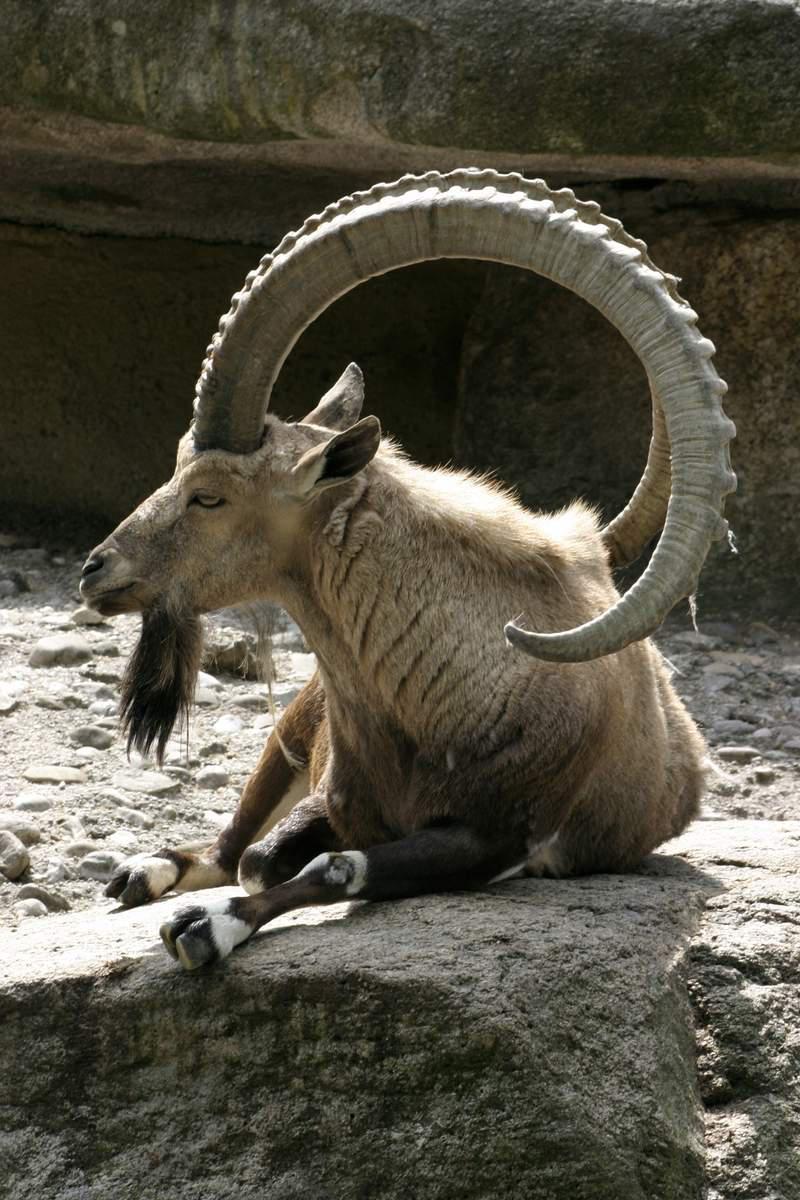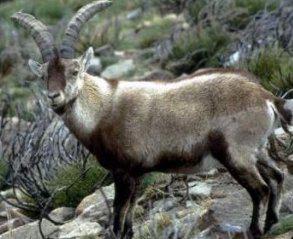The first image is the image on the left, the second image is the image on the right. Given the left and right images, does the statement "The left image contains one reclining long-horned goat, and the right image contains one long-horned goat standing in profile." hold true? Answer yes or no. Yes. The first image is the image on the left, the second image is the image on the right. Given the left and right images, does the statement "An ibex is laying down in the left image." hold true? Answer yes or no. Yes. 